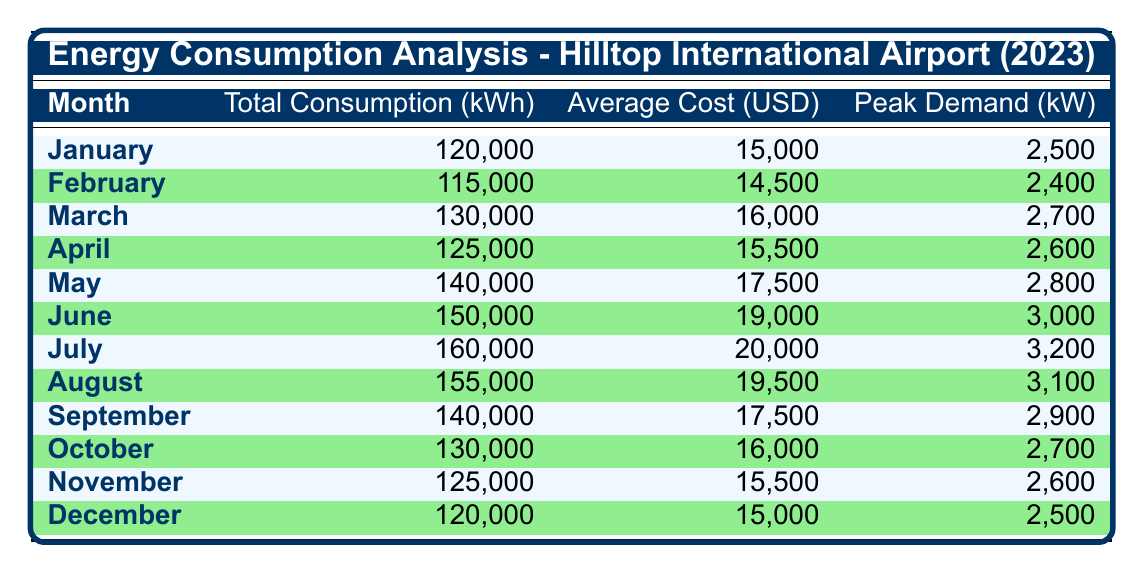What was the total energy consumption in July? The table indicates that the total energy consumption in July was 160,000 kWh, as specified in the MonthlyData for that month.
Answer: 160,000 kWh What was the average cost of energy for the month of June? According to the table, the average cost of energy in June was 19,000 USD, indicated in the respective row for that month.
Answer: 19,000 USD Which month had the highest peak demand. The highest peak demand recorded in the table was 3,200 kW in July, as noted in the PeakDemand column for that month.
Answer: July Was the average cost higher in May than in April? The average cost in May was 17,500 USD, which is higher than the 15,500 USD average cost in April, confirming that May indeed had a higher average cost.
Answer: Yes What is the total energy consumption from January to March? The total energy consumption for these months is calculated as follows: January (120,000 kWh) + February (115,000 kWh) + March (130,000 kWh) = 365,000 kWh. Therefore, the total energy consumption from January to March is 365,000 kWh.
Answer: 365,000 kWh Did the total energy consumption decrease from July to August? The total energy consumption in July was 160,000 kWh and decreased to 155,000 kWh in August. Thus, there was indeed a decrease in total energy consumption from July to August.
Answer: Yes What is the average total energy consumption for the second half of the year (July to December)? We first sum the total consumptions for these months: July (160,000 kWh) + August (155,000 kWh) + September (140,000 kWh) + October (130,000 kWh) + November (125,000 kWh) + December (120,000 kWh) = 930,000 kWh. Then we divide by 6 months to find the average: 930,000 kWh / 6 = 155,000 kWh.
Answer: 155,000 kWh Is the peak demand for December greater than that for February? The peak demand for December was 2,500 kW, while February's peak demand was 2,400 kW. Therefore, December does have a greater peak demand than February.
Answer: Yes What was the overall trend in average costs from January to December? Examining the average costs across the months shows a gradual increase until July (20,000 USD), after which it slightly declines in the subsequent months. The highest point was in July, and it decreased thereafter, indicating a peak before tapering off.
Answer: Fluctuating with a peak in July 